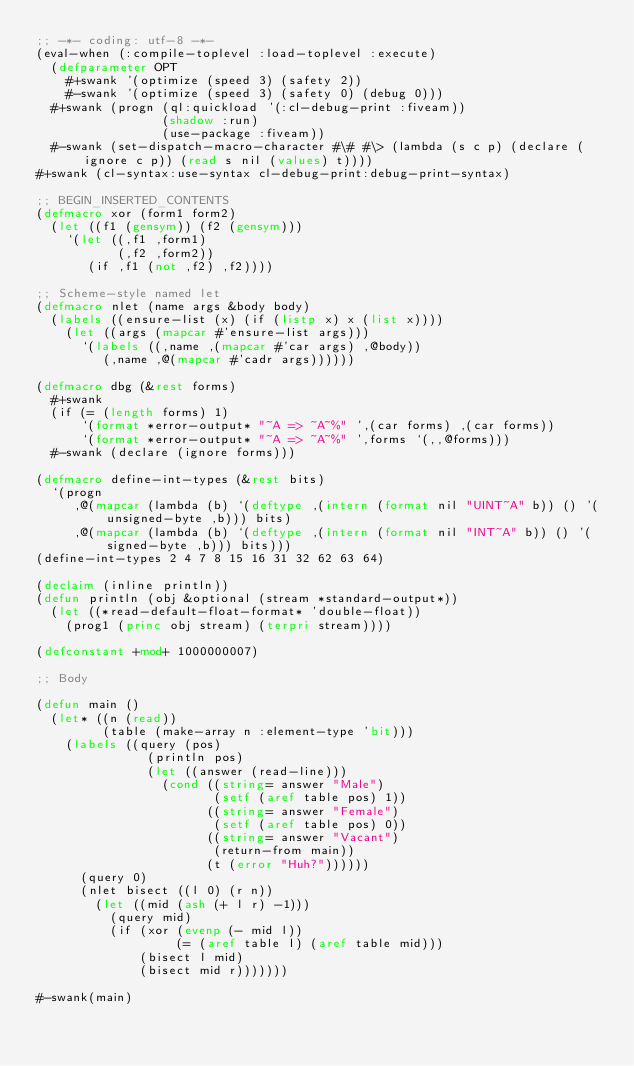Convert code to text. <code><loc_0><loc_0><loc_500><loc_500><_Lisp_>;; -*- coding: utf-8 -*-
(eval-when (:compile-toplevel :load-toplevel :execute)
  (defparameter OPT
    #+swank '(optimize (speed 3) (safety 2))
    #-swank '(optimize (speed 3) (safety 0) (debug 0)))
  #+swank (progn (ql:quickload '(:cl-debug-print :fiveam))
                 (shadow :run)
                 (use-package :fiveam))
  #-swank (set-dispatch-macro-character #\# #\> (lambda (s c p) (declare (ignore c p)) (read s nil (values) t))))
#+swank (cl-syntax:use-syntax cl-debug-print:debug-print-syntax)

;; BEGIN_INSERTED_CONTENTS
(defmacro xor (form1 form2)
  (let ((f1 (gensym)) (f2 (gensym)))
    `(let ((,f1 ,form1)
           (,f2 ,form2))
       (if ,f1 (not ,f2) ,f2))))

;; Scheme-style named let
(defmacro nlet (name args &body body)
  (labels ((ensure-list (x) (if (listp x) x (list x))))
    (let ((args (mapcar #'ensure-list args)))
      `(labels ((,name ,(mapcar #'car args) ,@body))
         (,name ,@(mapcar #'cadr args))))))

(defmacro dbg (&rest forms)
  #+swank
  (if (= (length forms) 1)
      `(format *error-output* "~A => ~A~%" ',(car forms) ,(car forms))
      `(format *error-output* "~A => ~A~%" ',forms `(,,@forms)))
  #-swank (declare (ignore forms)))

(defmacro define-int-types (&rest bits)
  `(progn
     ,@(mapcar (lambda (b) `(deftype ,(intern (format nil "UINT~A" b)) () '(unsigned-byte ,b))) bits)
     ,@(mapcar (lambda (b) `(deftype ,(intern (format nil "INT~A" b)) () '(signed-byte ,b))) bits)))
(define-int-types 2 4 7 8 15 16 31 32 62 63 64)

(declaim (inline println))
(defun println (obj &optional (stream *standard-output*))
  (let ((*read-default-float-format* 'double-float))
    (prog1 (princ obj stream) (terpri stream))))

(defconstant +mod+ 1000000007)

;; Body

(defun main ()
  (let* ((n (read))
         (table (make-array n :element-type 'bit)))
    (labels ((query (pos)
               (println pos)
               (let ((answer (read-line)))
                 (cond ((string= answer "Male")
                        (setf (aref table pos) 1))
                       ((string= answer "Female")
                        (setf (aref table pos) 0))
                       ((string= answer "Vacant")
                        (return-from main))
                       (t (error "Huh?"))))))
      (query 0)
      (nlet bisect ((l 0) (r n))
        (let ((mid (ash (+ l r) -1)))
          (query mid)
          (if (xor (evenp (- mid l))
                   (= (aref table l) (aref table mid)))
              (bisect l mid)
              (bisect mid r)))))))

#-swank(main)
</code> 